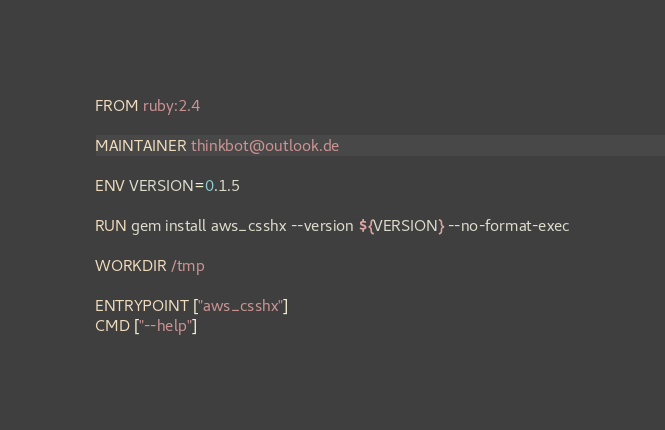<code> <loc_0><loc_0><loc_500><loc_500><_Dockerfile_>FROM ruby:2.4

MAINTAINER thinkbot@outlook.de

ENV VERSION=0.1.5

RUN gem install aws_csshx --version ${VERSION} --no-format-exec

WORKDIR /tmp

ENTRYPOINT ["aws_csshx"]
CMD ["--help"]
</code> 